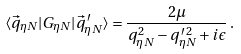Convert formula to latex. <formula><loc_0><loc_0><loc_500><loc_500>\langle \vec { q } _ { \eta N } | G _ { \eta N } | \vec { q } _ { \eta N } ^ { \, \prime } \rangle = \frac { 2 \mu } { q _ { \eta N } ^ { 2 } - q _ { \eta N } ^ { \, \prime \, 2 } + i \epsilon } \, .</formula> 